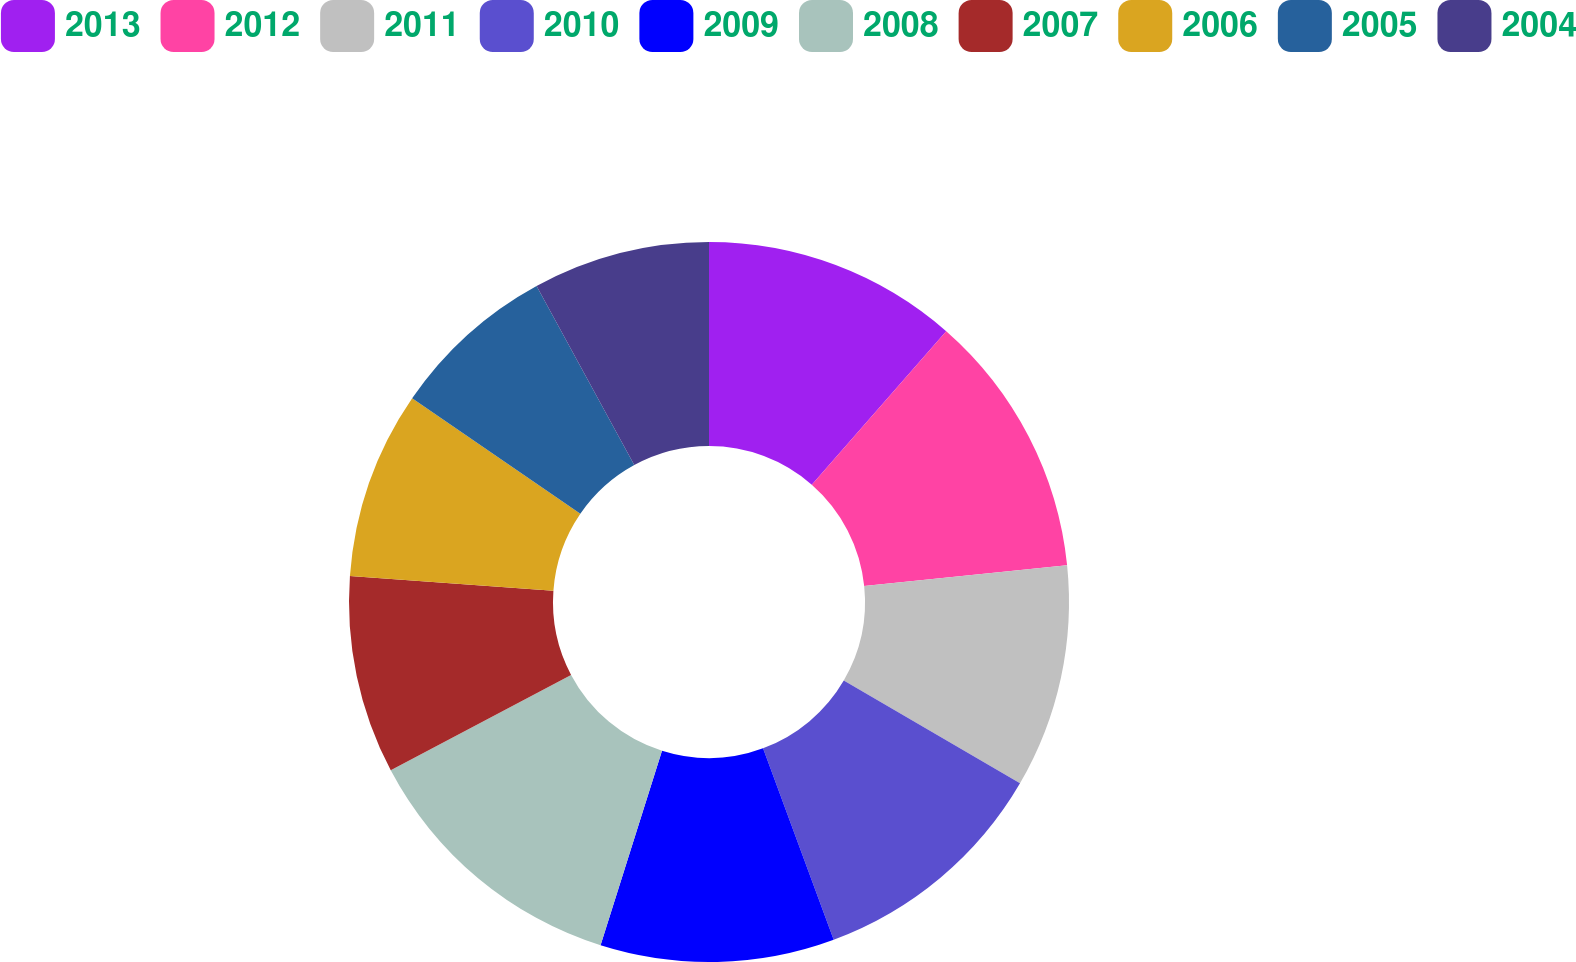Convert chart to OTSL. <chart><loc_0><loc_0><loc_500><loc_500><pie_chart><fcel>2013<fcel>2012<fcel>2011<fcel>2010<fcel>2009<fcel>2008<fcel>2007<fcel>2006<fcel>2005<fcel>2004<nl><fcel>11.45%<fcel>11.92%<fcel>10.03%<fcel>10.97%<fcel>10.5%<fcel>12.39%<fcel>8.89%<fcel>8.42%<fcel>7.48%<fcel>7.95%<nl></chart> 